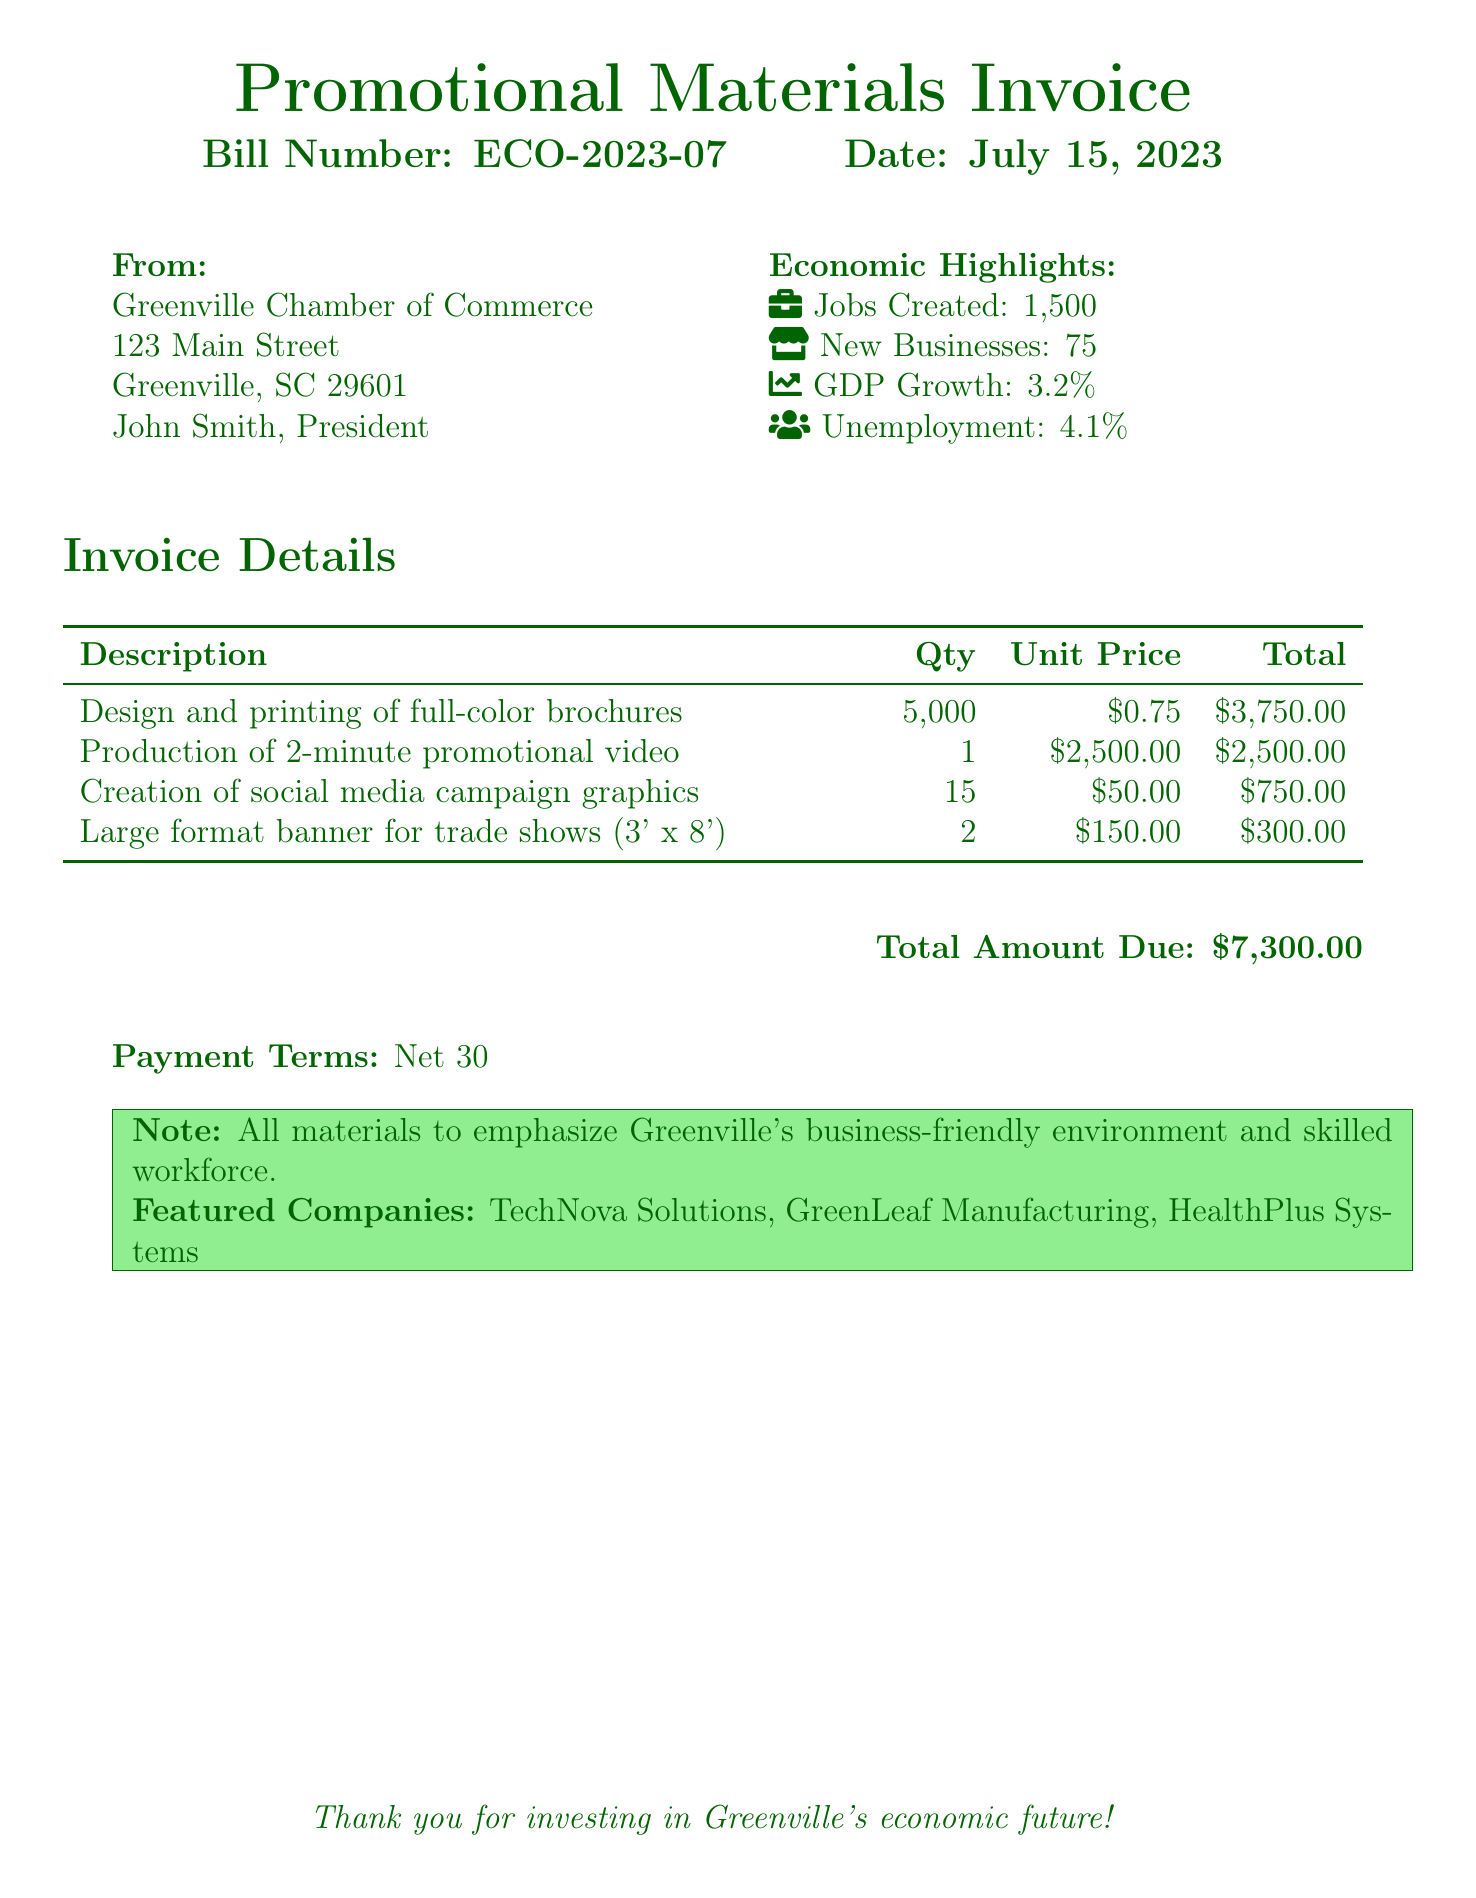What is the bill number? The bill number is stated prominently at the top of the document along with the date.
Answer: ECO-2023-07 How many jobs were created? The number of jobs created is highlighted in the economic section of the document.
Answer: 1,500 What is the total amount due? The total amount due is clearly listed at the bottom of the invoice details.
Answer: $7,300.00 When is the payment due? The payment terms section specifies the timeframe for payment after the invoice date.
Answer: Net 30 How many new businesses were created? The economic highlights section lists the number of new businesses.
Answer: 75 What is the unit price for the promotional video? The invoice details provide the unit price for the production of the video.
Answer: $2,500.00 What is the GDP growth percentage? The document mentions the GDP growth in the economic highlights section.
Answer: 3.2% What type of materials are emphasized in the note? The note specifies the focus of all materials presented in the promotion.
Answer: Greenville's business-friendly environment and skilled workforce How many large format banners were ordered? The quantity of large format banners is stated in the invoice details.
Answer: 2 